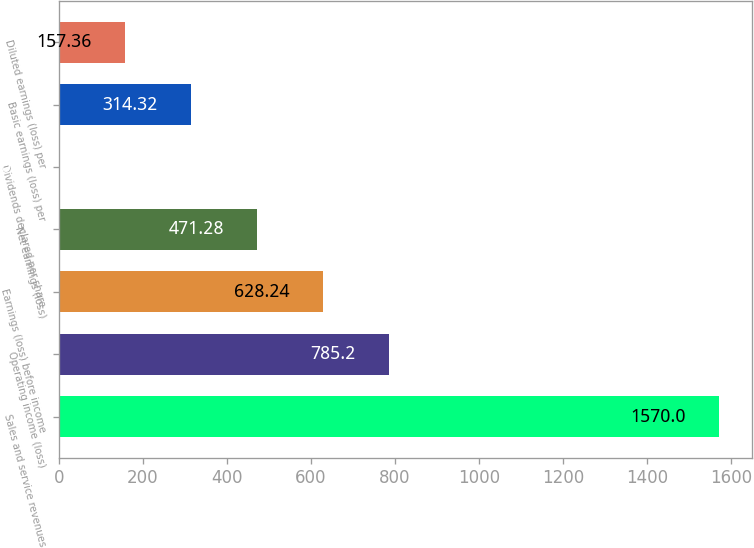Convert chart. <chart><loc_0><loc_0><loc_500><loc_500><bar_chart><fcel>Sales and service revenues<fcel>Operating income (loss)<fcel>Earnings (loss) before income<fcel>Net earnings (loss)<fcel>Dividends declared per share<fcel>Basic earnings (loss) per<fcel>Diluted earnings (loss) per<nl><fcel>1570<fcel>785.2<fcel>628.24<fcel>471.28<fcel>0.4<fcel>314.32<fcel>157.36<nl></chart> 